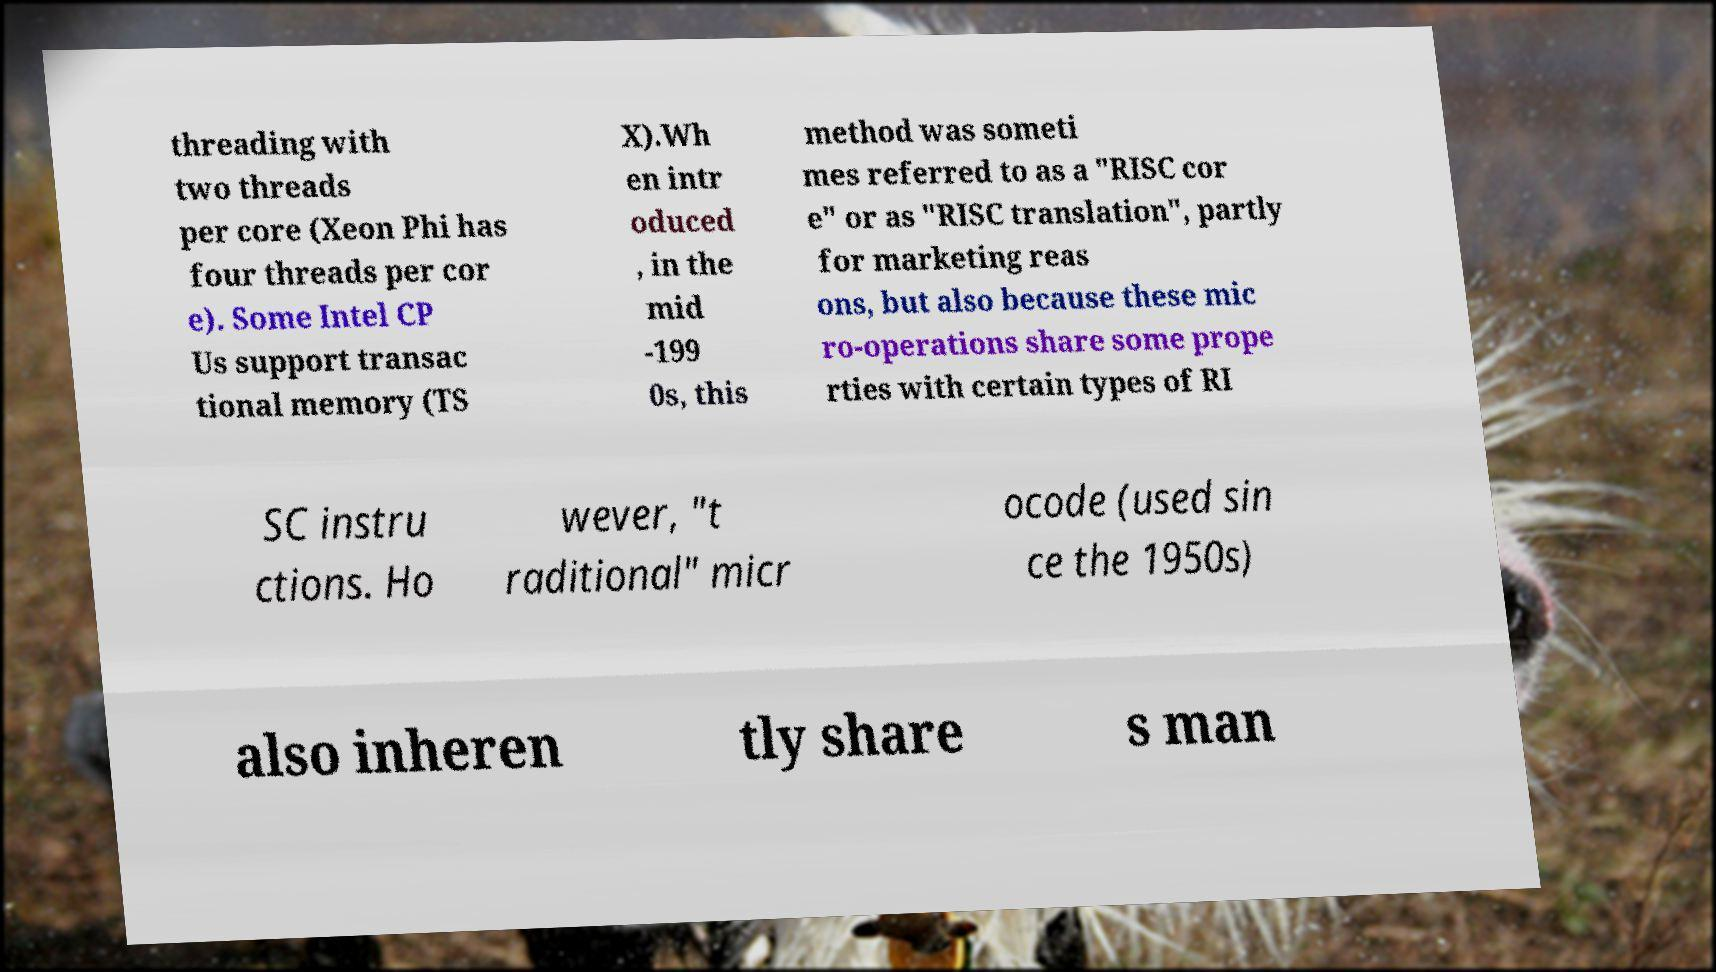Could you assist in decoding the text presented in this image and type it out clearly? threading with two threads per core (Xeon Phi has four threads per cor e). Some Intel CP Us support transac tional memory (TS X).Wh en intr oduced , in the mid -199 0s, this method was someti mes referred to as a "RISC cor e" or as "RISC translation", partly for marketing reas ons, but also because these mic ro-operations share some prope rties with certain types of RI SC instru ctions. Ho wever, "t raditional" micr ocode (used sin ce the 1950s) also inheren tly share s man 